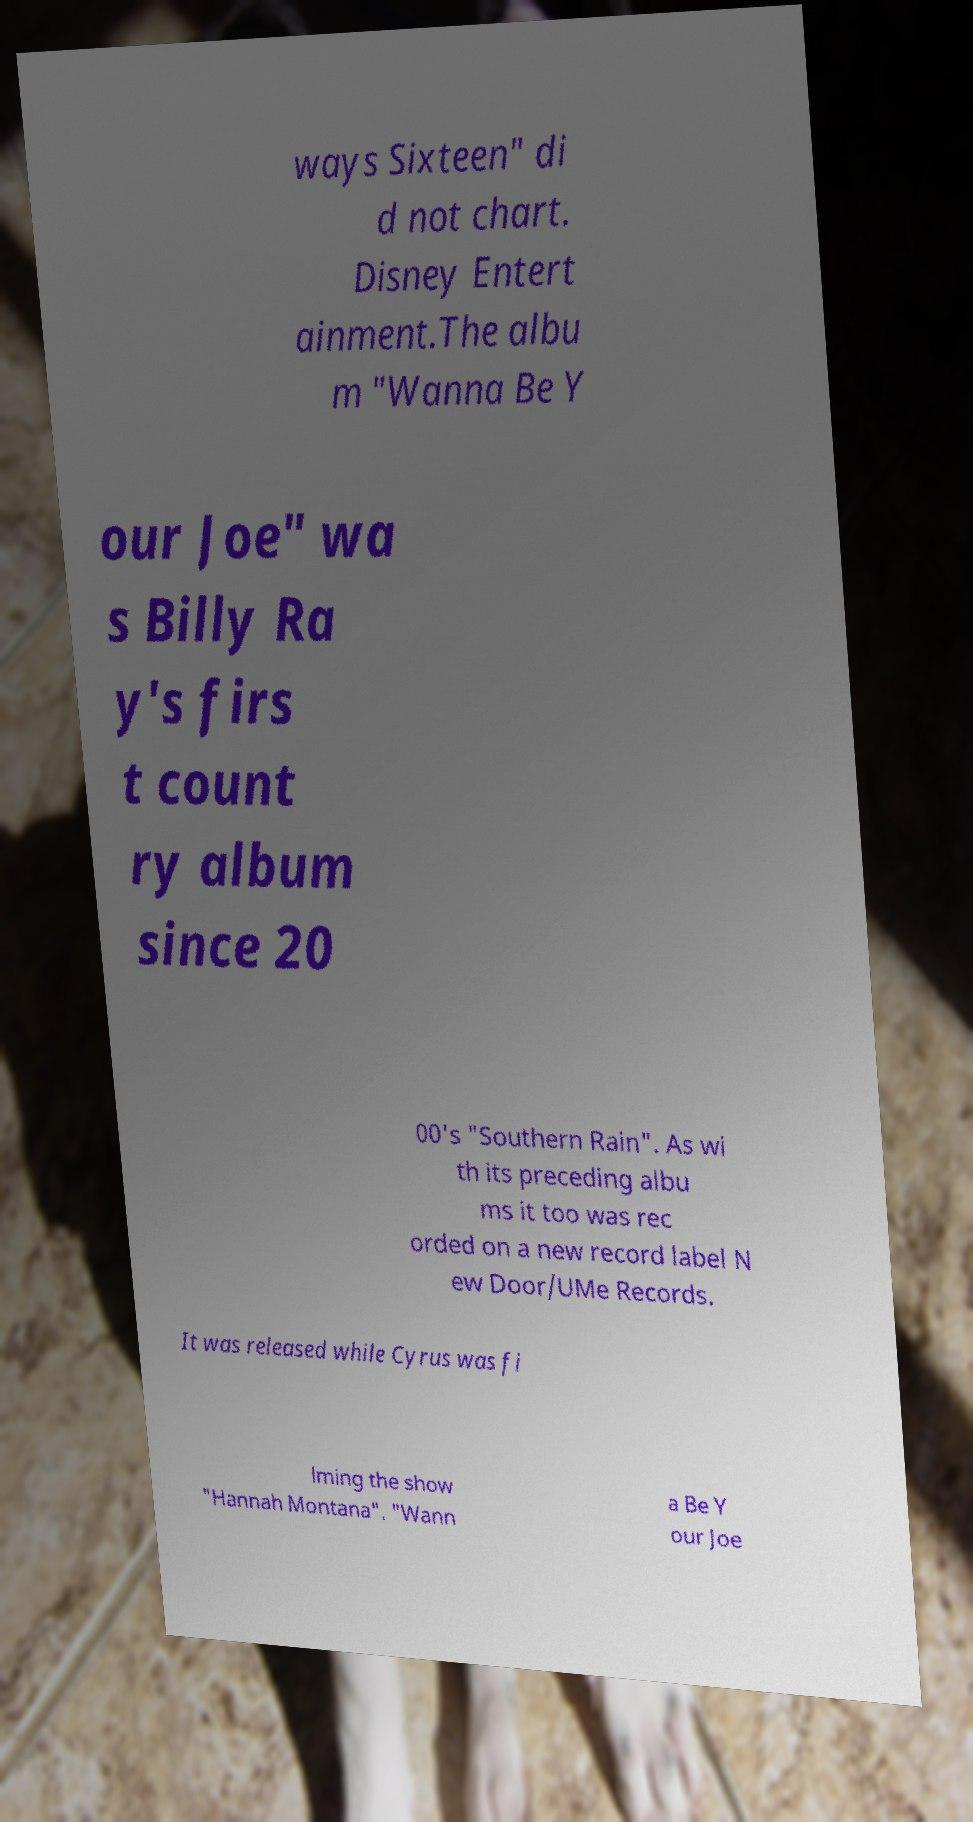Could you extract and type out the text from this image? ways Sixteen" di d not chart. Disney Entert ainment.The albu m "Wanna Be Y our Joe" wa s Billy Ra y's firs t count ry album since 20 00's "Southern Rain". As wi th its preceding albu ms it too was rec orded on a new record label N ew Door/UMe Records. It was released while Cyrus was fi lming the show "Hannah Montana". "Wann a Be Y our Joe 